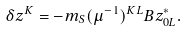<formula> <loc_0><loc_0><loc_500><loc_500>\delta z ^ { K } = - m _ { S } ( \mu ^ { - 1 } ) ^ { K L } B z _ { 0 L } ^ { * } .</formula> 